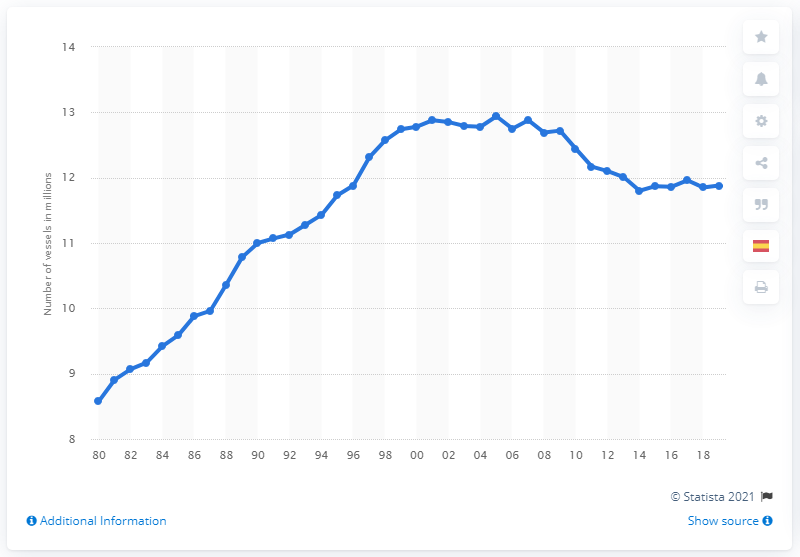Specify some key components in this picture. In 2019, a total of 11.88 vessels were registered in the United States. In 2018, a total of 11.88 vessels were registered in the United States. In 2019, a total of 11.88 vessels were registered in the United States. 